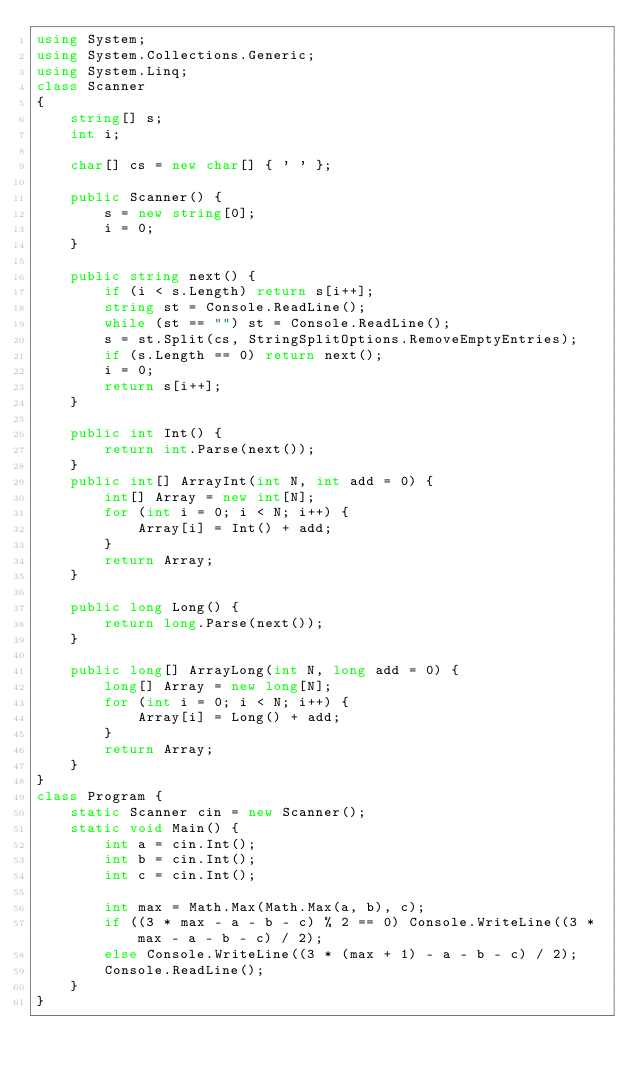<code> <loc_0><loc_0><loc_500><loc_500><_C#_>using System;
using System.Collections.Generic;
using System.Linq;
class Scanner
{
    string[] s;
    int i;

    char[] cs = new char[] { ' ' };

    public Scanner() {
        s = new string[0];
        i = 0;
    }

    public string next() {
        if (i < s.Length) return s[i++];
        string st = Console.ReadLine();
        while (st == "") st = Console.ReadLine();
        s = st.Split(cs, StringSplitOptions.RemoveEmptyEntries);
        if (s.Length == 0) return next();
        i = 0;
        return s[i++];
    }

    public int Int() {
        return int.Parse(next());
    }
    public int[] ArrayInt(int N, int add = 0) {
        int[] Array = new int[N];
        for (int i = 0; i < N; i++) {
            Array[i] = Int() + add;
        }
        return Array;
    }

    public long Long() {
        return long.Parse(next());
    }

    public long[] ArrayLong(int N, long add = 0) {
        long[] Array = new long[N];
        for (int i = 0; i < N; i++) {
            Array[i] = Long() + add;
        }
        return Array;
    }
}
class Program {
    static Scanner cin = new Scanner();
    static void Main() {
        int a = cin.Int();
        int b = cin.Int();
        int c = cin.Int();

        int max = Math.Max(Math.Max(a, b), c);
        if ((3 * max - a - b - c) % 2 == 0) Console.WriteLine((3 * max - a - b - c) / 2);
        else Console.WriteLine((3 * (max + 1) - a - b - c) / 2);
        Console.ReadLine();
    }
}</code> 